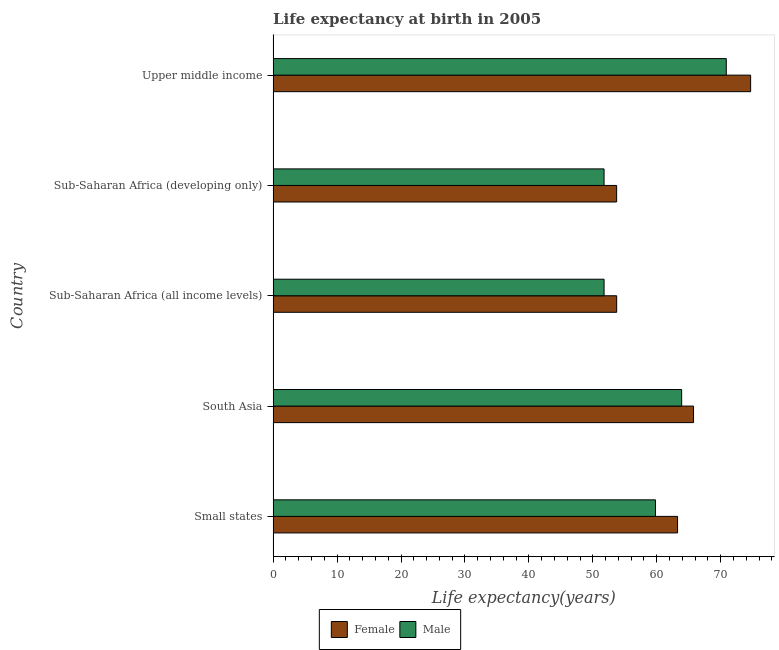How many different coloured bars are there?
Keep it short and to the point. 2. In how many cases, is the number of bars for a given country not equal to the number of legend labels?
Your answer should be very brief. 0. What is the life expectancy(male) in South Asia?
Your answer should be very brief. 63.9. Across all countries, what is the maximum life expectancy(female)?
Provide a succinct answer. 74.68. Across all countries, what is the minimum life expectancy(male)?
Give a very brief answer. 51.76. In which country was the life expectancy(male) maximum?
Give a very brief answer. Upper middle income. In which country was the life expectancy(male) minimum?
Offer a terse response. Sub-Saharan Africa (developing only). What is the total life expectancy(female) in the graph?
Give a very brief answer. 311.15. What is the difference between the life expectancy(male) in Small states and that in Sub-Saharan Africa (developing only)?
Provide a succinct answer. 8.04. What is the difference between the life expectancy(male) in Small states and the life expectancy(female) in Sub-Saharan Africa (all income levels)?
Give a very brief answer. 6.07. What is the average life expectancy(male) per country?
Make the answer very short. 59.62. What is the difference between the life expectancy(male) and life expectancy(female) in Small states?
Offer a terse response. -3.46. In how many countries, is the life expectancy(male) greater than 44 years?
Provide a succinct answer. 5. What is the ratio of the life expectancy(female) in Sub-Saharan Africa (all income levels) to that in Sub-Saharan Africa (developing only)?
Offer a very short reply. 1. Is the life expectancy(female) in Small states less than that in Sub-Saharan Africa (all income levels)?
Provide a succinct answer. No. Is the difference between the life expectancy(male) in Sub-Saharan Africa (all income levels) and Sub-Saharan Africa (developing only) greater than the difference between the life expectancy(female) in Sub-Saharan Africa (all income levels) and Sub-Saharan Africa (developing only)?
Offer a terse response. No. What is the difference between the highest and the second highest life expectancy(male)?
Provide a short and direct response. 6.98. What is the difference between the highest and the lowest life expectancy(female)?
Give a very brief answer. 20.95. In how many countries, is the life expectancy(female) greater than the average life expectancy(female) taken over all countries?
Offer a very short reply. 3. What does the 2nd bar from the top in Small states represents?
Provide a succinct answer. Female. How many bars are there?
Your response must be concise. 10. Are all the bars in the graph horizontal?
Keep it short and to the point. Yes. How many countries are there in the graph?
Provide a succinct answer. 5. What is the difference between two consecutive major ticks on the X-axis?
Offer a terse response. 10. Are the values on the major ticks of X-axis written in scientific E-notation?
Provide a short and direct response. No. Does the graph contain grids?
Give a very brief answer. No. Where does the legend appear in the graph?
Keep it short and to the point. Bottom center. How many legend labels are there?
Your answer should be very brief. 2. What is the title of the graph?
Your answer should be very brief. Life expectancy at birth in 2005. Does "IMF concessional" appear as one of the legend labels in the graph?
Provide a succinct answer. No. What is the label or title of the X-axis?
Offer a very short reply. Life expectancy(years). What is the label or title of the Y-axis?
Offer a very short reply. Country. What is the Life expectancy(years) in Female in Small states?
Your response must be concise. 63.25. What is the Life expectancy(years) of Male in Small states?
Make the answer very short. 59.8. What is the Life expectancy(years) of Female in South Asia?
Provide a succinct answer. 65.75. What is the Life expectancy(years) in Male in South Asia?
Your answer should be very brief. 63.9. What is the Life expectancy(years) in Female in Sub-Saharan Africa (all income levels)?
Provide a succinct answer. 53.73. What is the Life expectancy(years) in Male in Sub-Saharan Africa (all income levels)?
Your answer should be compact. 51.76. What is the Life expectancy(years) of Female in Sub-Saharan Africa (developing only)?
Offer a terse response. 53.73. What is the Life expectancy(years) of Male in Sub-Saharan Africa (developing only)?
Your answer should be compact. 51.76. What is the Life expectancy(years) of Female in Upper middle income?
Make the answer very short. 74.68. What is the Life expectancy(years) in Male in Upper middle income?
Offer a very short reply. 70.88. Across all countries, what is the maximum Life expectancy(years) in Female?
Give a very brief answer. 74.68. Across all countries, what is the maximum Life expectancy(years) of Male?
Your answer should be compact. 70.88. Across all countries, what is the minimum Life expectancy(years) of Female?
Make the answer very short. 53.73. Across all countries, what is the minimum Life expectancy(years) in Male?
Provide a short and direct response. 51.76. What is the total Life expectancy(years) of Female in the graph?
Give a very brief answer. 311.15. What is the total Life expectancy(years) of Male in the graph?
Make the answer very short. 298.09. What is the difference between the Life expectancy(years) in Female in Small states and that in South Asia?
Give a very brief answer. -2.5. What is the difference between the Life expectancy(years) in Male in Small states and that in South Asia?
Your answer should be very brief. -4.1. What is the difference between the Life expectancy(years) of Female in Small states and that in Sub-Saharan Africa (all income levels)?
Provide a short and direct response. 9.52. What is the difference between the Life expectancy(years) of Male in Small states and that in Sub-Saharan Africa (all income levels)?
Make the answer very short. 8.04. What is the difference between the Life expectancy(years) of Female in Small states and that in Sub-Saharan Africa (developing only)?
Offer a very short reply. 9.53. What is the difference between the Life expectancy(years) in Male in Small states and that in Sub-Saharan Africa (developing only)?
Make the answer very short. 8.04. What is the difference between the Life expectancy(years) in Female in Small states and that in Upper middle income?
Your response must be concise. -11.43. What is the difference between the Life expectancy(years) in Male in Small states and that in Upper middle income?
Ensure brevity in your answer.  -11.08. What is the difference between the Life expectancy(years) in Female in South Asia and that in Sub-Saharan Africa (all income levels)?
Your answer should be very brief. 12.02. What is the difference between the Life expectancy(years) in Male in South Asia and that in Sub-Saharan Africa (all income levels)?
Your answer should be very brief. 12.13. What is the difference between the Life expectancy(years) in Female in South Asia and that in Sub-Saharan Africa (developing only)?
Your response must be concise. 12.02. What is the difference between the Life expectancy(years) of Male in South Asia and that in Sub-Saharan Africa (developing only)?
Provide a short and direct response. 12.14. What is the difference between the Life expectancy(years) of Female in South Asia and that in Upper middle income?
Your response must be concise. -8.93. What is the difference between the Life expectancy(years) of Male in South Asia and that in Upper middle income?
Your answer should be very brief. -6.98. What is the difference between the Life expectancy(years) of Female in Sub-Saharan Africa (all income levels) and that in Sub-Saharan Africa (developing only)?
Provide a short and direct response. 0. What is the difference between the Life expectancy(years) of Male in Sub-Saharan Africa (all income levels) and that in Sub-Saharan Africa (developing only)?
Your response must be concise. 0. What is the difference between the Life expectancy(years) of Female in Sub-Saharan Africa (all income levels) and that in Upper middle income?
Your answer should be compact. -20.95. What is the difference between the Life expectancy(years) in Male in Sub-Saharan Africa (all income levels) and that in Upper middle income?
Give a very brief answer. -19.11. What is the difference between the Life expectancy(years) of Female in Sub-Saharan Africa (developing only) and that in Upper middle income?
Give a very brief answer. -20.95. What is the difference between the Life expectancy(years) of Male in Sub-Saharan Africa (developing only) and that in Upper middle income?
Offer a very short reply. -19.12. What is the difference between the Life expectancy(years) of Female in Small states and the Life expectancy(years) of Male in South Asia?
Make the answer very short. -0.64. What is the difference between the Life expectancy(years) in Female in Small states and the Life expectancy(years) in Male in Sub-Saharan Africa (all income levels)?
Provide a succinct answer. 11.49. What is the difference between the Life expectancy(years) in Female in Small states and the Life expectancy(years) in Male in Sub-Saharan Africa (developing only)?
Offer a very short reply. 11.5. What is the difference between the Life expectancy(years) of Female in Small states and the Life expectancy(years) of Male in Upper middle income?
Provide a short and direct response. -7.62. What is the difference between the Life expectancy(years) in Female in South Asia and the Life expectancy(years) in Male in Sub-Saharan Africa (all income levels)?
Offer a terse response. 13.99. What is the difference between the Life expectancy(years) in Female in South Asia and the Life expectancy(years) in Male in Sub-Saharan Africa (developing only)?
Offer a terse response. 13.99. What is the difference between the Life expectancy(years) of Female in South Asia and the Life expectancy(years) of Male in Upper middle income?
Your answer should be compact. -5.12. What is the difference between the Life expectancy(years) of Female in Sub-Saharan Africa (all income levels) and the Life expectancy(years) of Male in Sub-Saharan Africa (developing only)?
Give a very brief answer. 1.97. What is the difference between the Life expectancy(years) of Female in Sub-Saharan Africa (all income levels) and the Life expectancy(years) of Male in Upper middle income?
Offer a terse response. -17.14. What is the difference between the Life expectancy(years) of Female in Sub-Saharan Africa (developing only) and the Life expectancy(years) of Male in Upper middle income?
Provide a succinct answer. -17.15. What is the average Life expectancy(years) in Female per country?
Offer a terse response. 62.23. What is the average Life expectancy(years) of Male per country?
Make the answer very short. 59.62. What is the difference between the Life expectancy(years) of Female and Life expectancy(years) of Male in Small states?
Make the answer very short. 3.46. What is the difference between the Life expectancy(years) in Female and Life expectancy(years) in Male in South Asia?
Make the answer very short. 1.86. What is the difference between the Life expectancy(years) in Female and Life expectancy(years) in Male in Sub-Saharan Africa (all income levels)?
Ensure brevity in your answer.  1.97. What is the difference between the Life expectancy(years) of Female and Life expectancy(years) of Male in Sub-Saharan Africa (developing only)?
Your answer should be compact. 1.97. What is the difference between the Life expectancy(years) of Female and Life expectancy(years) of Male in Upper middle income?
Your response must be concise. 3.81. What is the ratio of the Life expectancy(years) of Male in Small states to that in South Asia?
Offer a terse response. 0.94. What is the ratio of the Life expectancy(years) in Female in Small states to that in Sub-Saharan Africa (all income levels)?
Your answer should be compact. 1.18. What is the ratio of the Life expectancy(years) in Male in Small states to that in Sub-Saharan Africa (all income levels)?
Ensure brevity in your answer.  1.16. What is the ratio of the Life expectancy(years) in Female in Small states to that in Sub-Saharan Africa (developing only)?
Offer a terse response. 1.18. What is the ratio of the Life expectancy(years) of Male in Small states to that in Sub-Saharan Africa (developing only)?
Your response must be concise. 1.16. What is the ratio of the Life expectancy(years) of Female in Small states to that in Upper middle income?
Keep it short and to the point. 0.85. What is the ratio of the Life expectancy(years) of Male in Small states to that in Upper middle income?
Your answer should be compact. 0.84. What is the ratio of the Life expectancy(years) in Female in South Asia to that in Sub-Saharan Africa (all income levels)?
Your answer should be very brief. 1.22. What is the ratio of the Life expectancy(years) in Male in South Asia to that in Sub-Saharan Africa (all income levels)?
Make the answer very short. 1.23. What is the ratio of the Life expectancy(years) of Female in South Asia to that in Sub-Saharan Africa (developing only)?
Your answer should be compact. 1.22. What is the ratio of the Life expectancy(years) of Male in South Asia to that in Sub-Saharan Africa (developing only)?
Provide a succinct answer. 1.23. What is the ratio of the Life expectancy(years) of Female in South Asia to that in Upper middle income?
Offer a very short reply. 0.88. What is the ratio of the Life expectancy(years) of Male in South Asia to that in Upper middle income?
Your response must be concise. 0.9. What is the ratio of the Life expectancy(years) of Female in Sub-Saharan Africa (all income levels) to that in Sub-Saharan Africa (developing only)?
Your answer should be compact. 1. What is the ratio of the Life expectancy(years) in Female in Sub-Saharan Africa (all income levels) to that in Upper middle income?
Offer a terse response. 0.72. What is the ratio of the Life expectancy(years) in Male in Sub-Saharan Africa (all income levels) to that in Upper middle income?
Keep it short and to the point. 0.73. What is the ratio of the Life expectancy(years) of Female in Sub-Saharan Africa (developing only) to that in Upper middle income?
Offer a terse response. 0.72. What is the ratio of the Life expectancy(years) of Male in Sub-Saharan Africa (developing only) to that in Upper middle income?
Keep it short and to the point. 0.73. What is the difference between the highest and the second highest Life expectancy(years) of Female?
Provide a short and direct response. 8.93. What is the difference between the highest and the second highest Life expectancy(years) of Male?
Offer a terse response. 6.98. What is the difference between the highest and the lowest Life expectancy(years) in Female?
Keep it short and to the point. 20.95. What is the difference between the highest and the lowest Life expectancy(years) of Male?
Your answer should be compact. 19.12. 